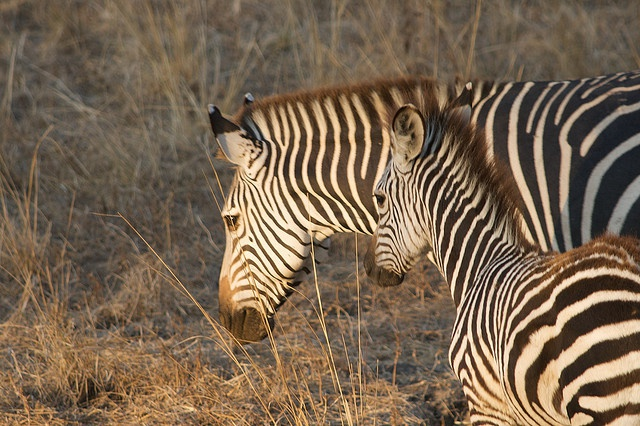Describe the objects in this image and their specific colors. I can see zebra in gray, black, maroon, and tan tones and zebra in gray, black, tan, and maroon tones in this image. 